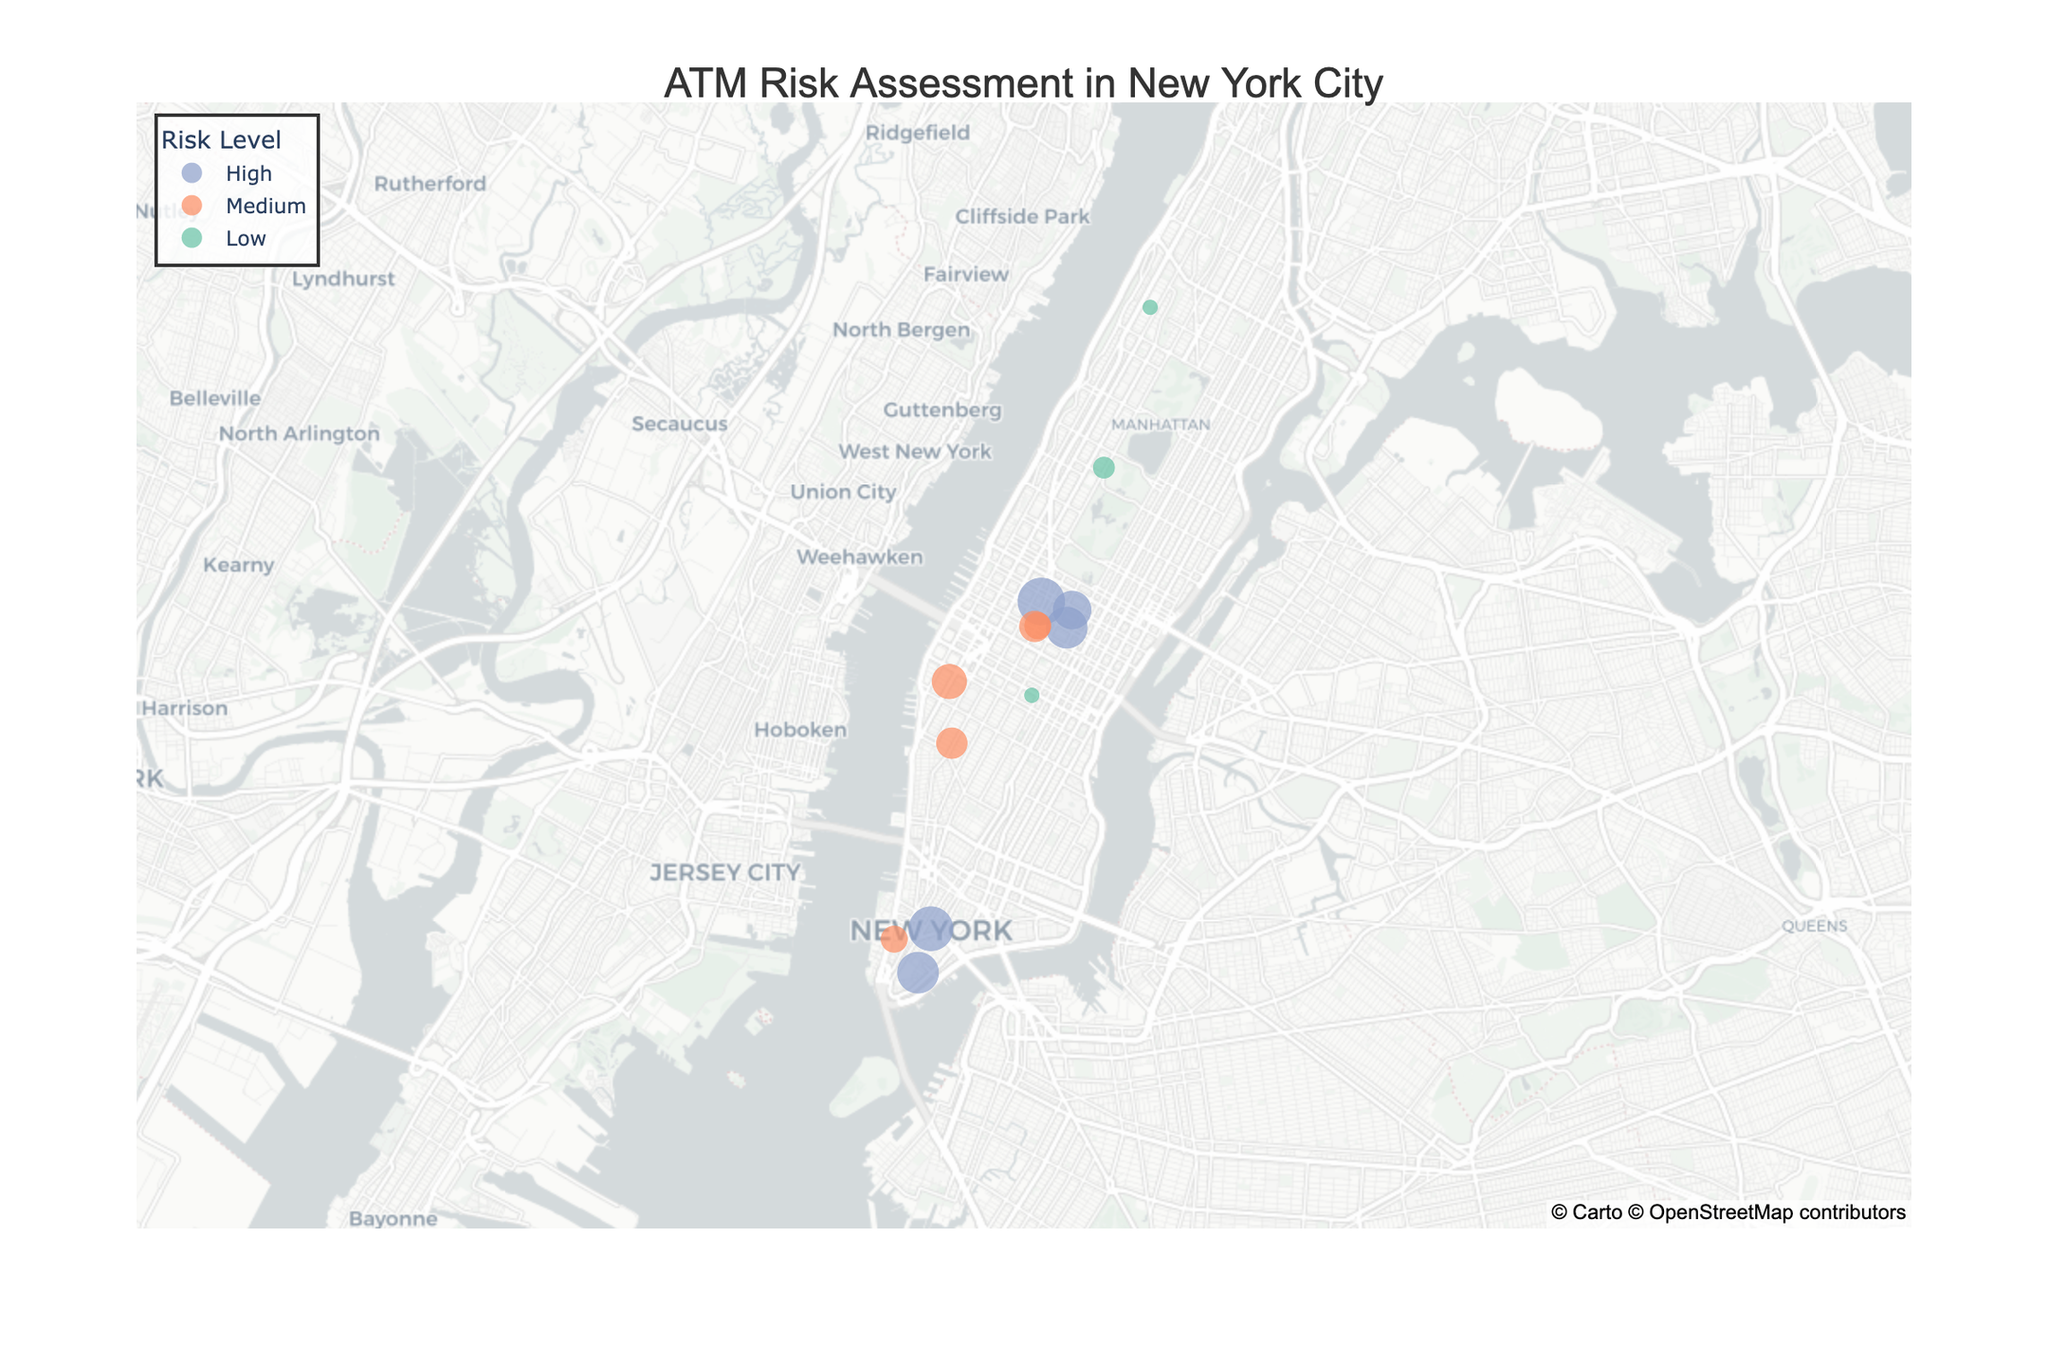How many ATMs have a High risk level? By visually examining the map, identify the locations marked with the color associated with High risk. Count these points.
Answer: 5 What is the title of the figure? Look at the top of the figure where the title is clearly displayed.
Answer: ATM Risk Assessment in New York City Which ATM has the highest number of incidents in the past year? Find the point on the map that has the largest size, and check the hover information for the exact number of incidents.
Answer: Times Square Visitor Center (ATM012) How many ATMs have a Low risk level and how many incidents do they collectively account for? Identify all the points marked with the color for Low risk, count them, and sum up their incidents values.
Answer: 5 ATMs, 4 incidents Which location is at coordinates (40.7589, -73.9851)? Check the hover information by finding the exact coordinates given on the map.
Answer: Midtown Manhattan Branch How does the number of incidents compare between the Rockefeller Center and Chelsea Market locations? Look at the hover information for Rockefeller Center and Chelsea Market and compare the number of incidents listed.
Answer: 6 (Rockefeller Center) vs 5 (Chelsea Market) What is the average number of incidents for ATMs with a Medium risk level? Identify ATMs with Medium risk, sum their incidents, and divide by the number of these ATMs. Calculation is (4 + 3 + 5 + 4 + 3) / 5.
Answer: 3.8 Which High-risk ATM has the least number of incidents? Look at all High risk ATMs and check the hover information to identify the one with the smallest size (least incidents).
Answer: Rockefeller Center (6 incidents) What risk level is associated with the ATM located at Empire State Building Kiosk? Use the hover information to check the risk level for Empire State Building Kiosk.
Answer: Low What is the median number of incidents for all ATMs? List all incidents numbers (8, 4, 1, 7, 0, 3, 5, 2, 1, 6, 4, 9, 3, 7, 0), order them (0, 0, 1, 1, 2, 3, 3, 4, 4, 5, 6, 7, 7, 8, 9) and find the middle number.
Answer: 4 